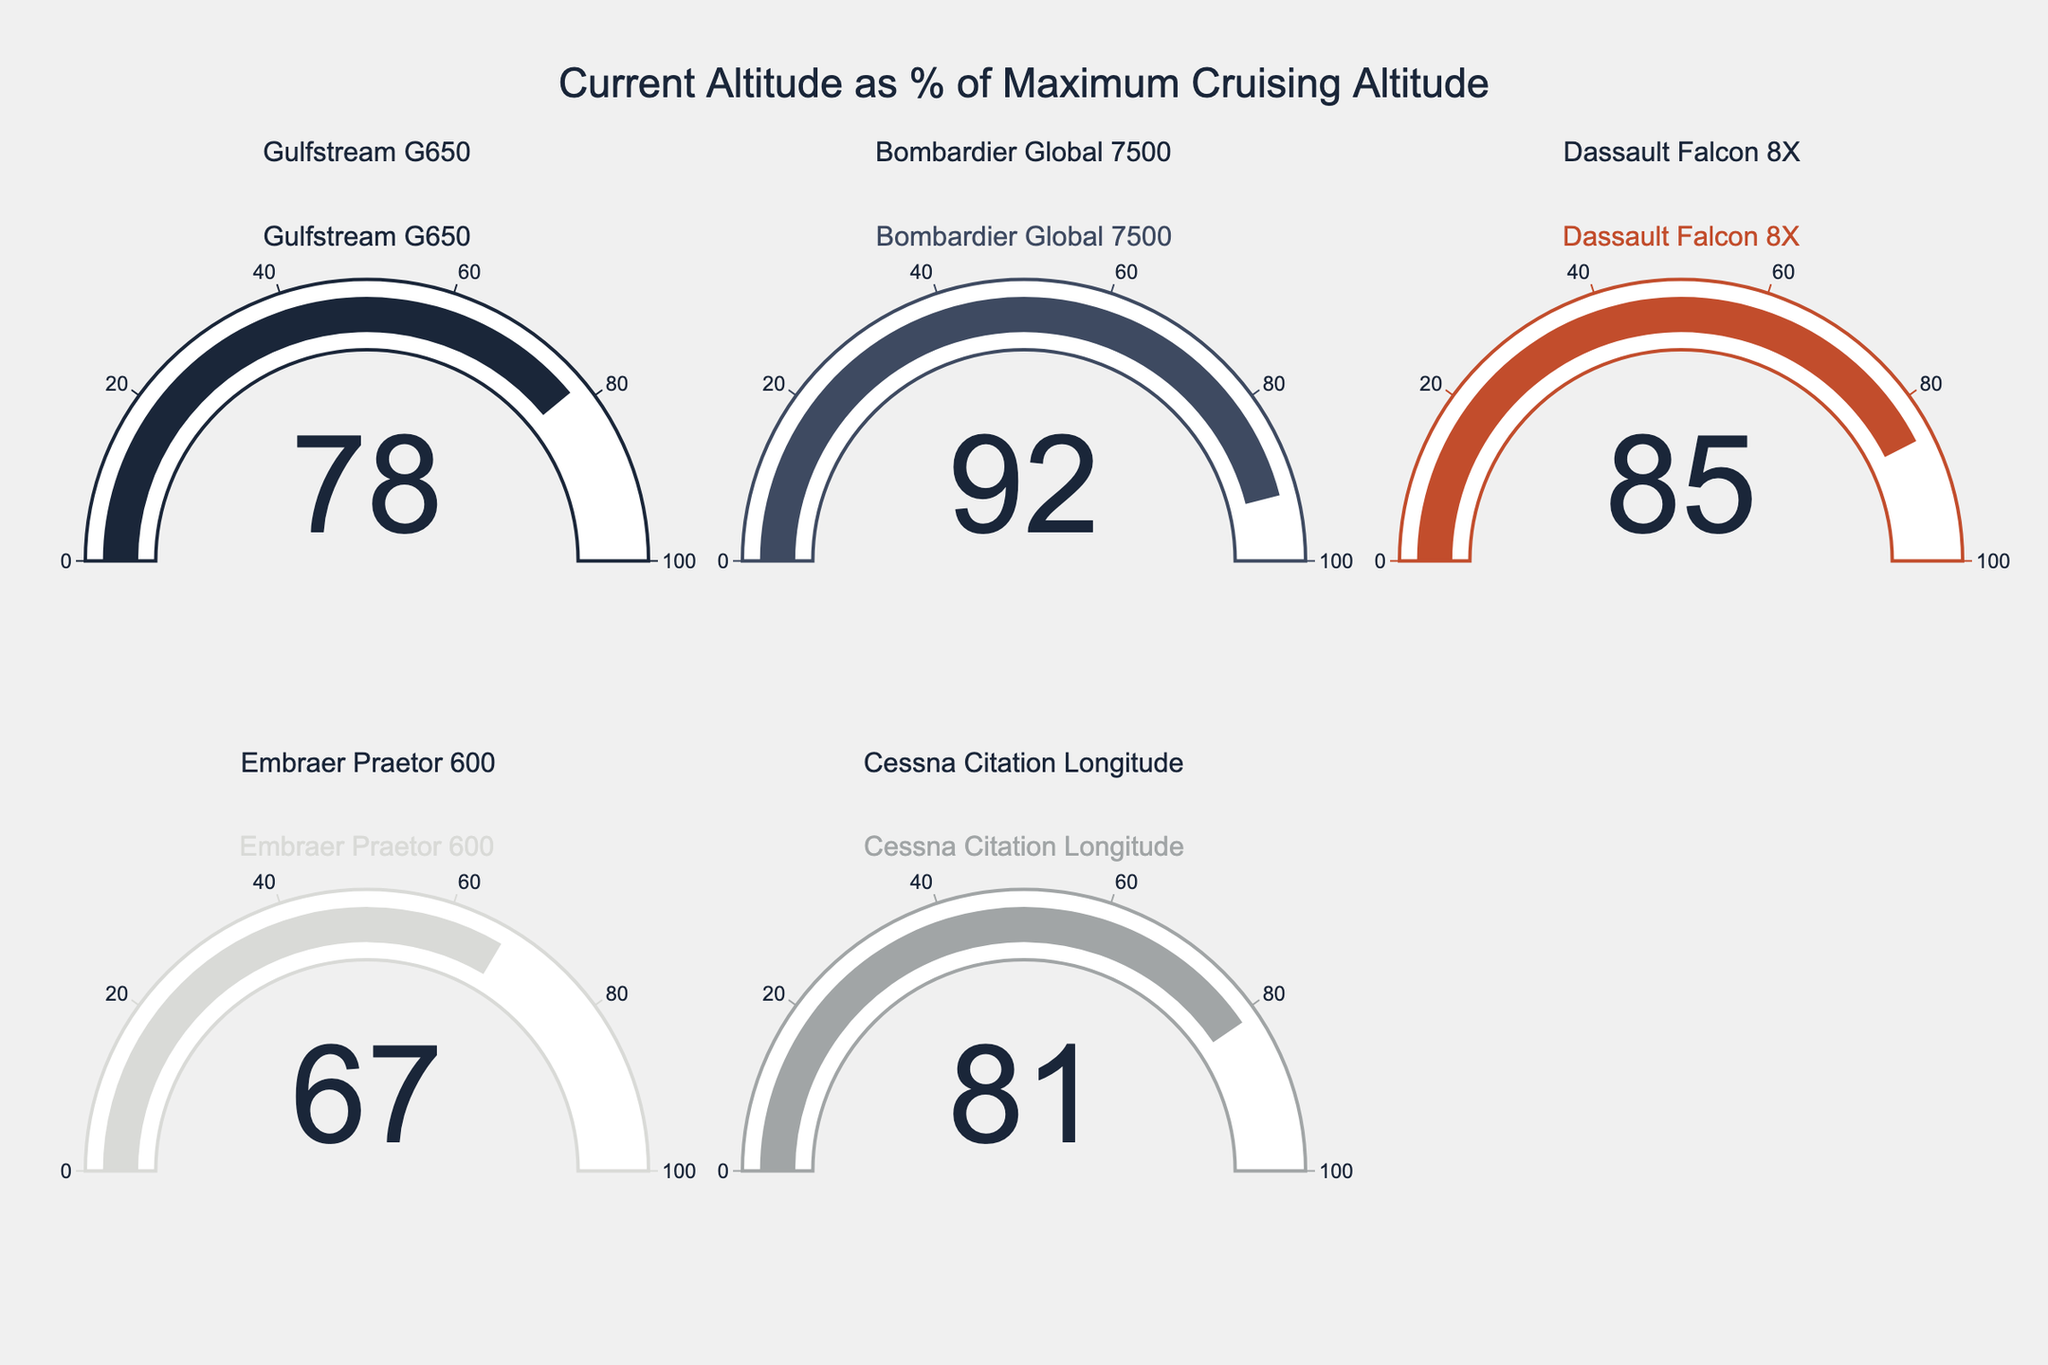What's the title of the chart? The title of the chart is shown at the top of the figure. It reads "Current Altitude as % of Maximum Cruising Altitude" in a large font.
Answer: Current Altitude as % of Maximum Cruising Altitude How many aircraft models are represented in the chart? The chart has gauges for five aircraft models based on the subplot titles and the number of gauges.
Answer: Five Which aircraft has the highest current altitude percentage? By looking at the gauge values, the Bombardier Global 7500 has the highest current altitude percentage of 92%.
Answer: Bombardier Global 7500 What color is used to indicate the Gulfstream G650's section of the chart? The Gulfstream G650's section is indicated with the first color from the color scale, which is a dark blue (#1a2639).
Answer: Dark blue Which aircraft has a current altitude percentage of 81%? The gauge for the Cessna Citation Longitude shows a value of 81%.
Answer: Cessna Citation Longitude What is the difference in current altitude percentage between the Dassault Falcon 8X and the Embraer Praetor 600? The current altitude percentage for the Dassault Falcon 8X is 85%, and for the Embraer Praetor 600, it is 67%. The difference is 85% - 67% = 18%.
Answer: 18% Which aircraft has a lower current altitude percentage: Gulfstream G650 or Dassault Falcon 8X? By comparing the values, the Gulfstream G650 has 78% and the Dassault Falcon 8X has 85%. Therefore, the Gulfstream G650 has a lower current altitude percentage.
Answer: Gulfstream G650 What is the average current altitude percentage of all the aircraft? Sum the current altitude percentages: 78% + 92% + 85% + 67% + 81% = 403%. Divide by the number of aircraft (5): 403% / 5 = 80.6%.
Answer: 80.6% What is the percentage difference between the highest and lowest current altitude percentages? The highest current altitude percentage is 92% (Bombardier Global 7500), and the lowest is 67% (Embraer Praetor 600). The difference is 92% - 67% = 25%.
Answer: 25% 